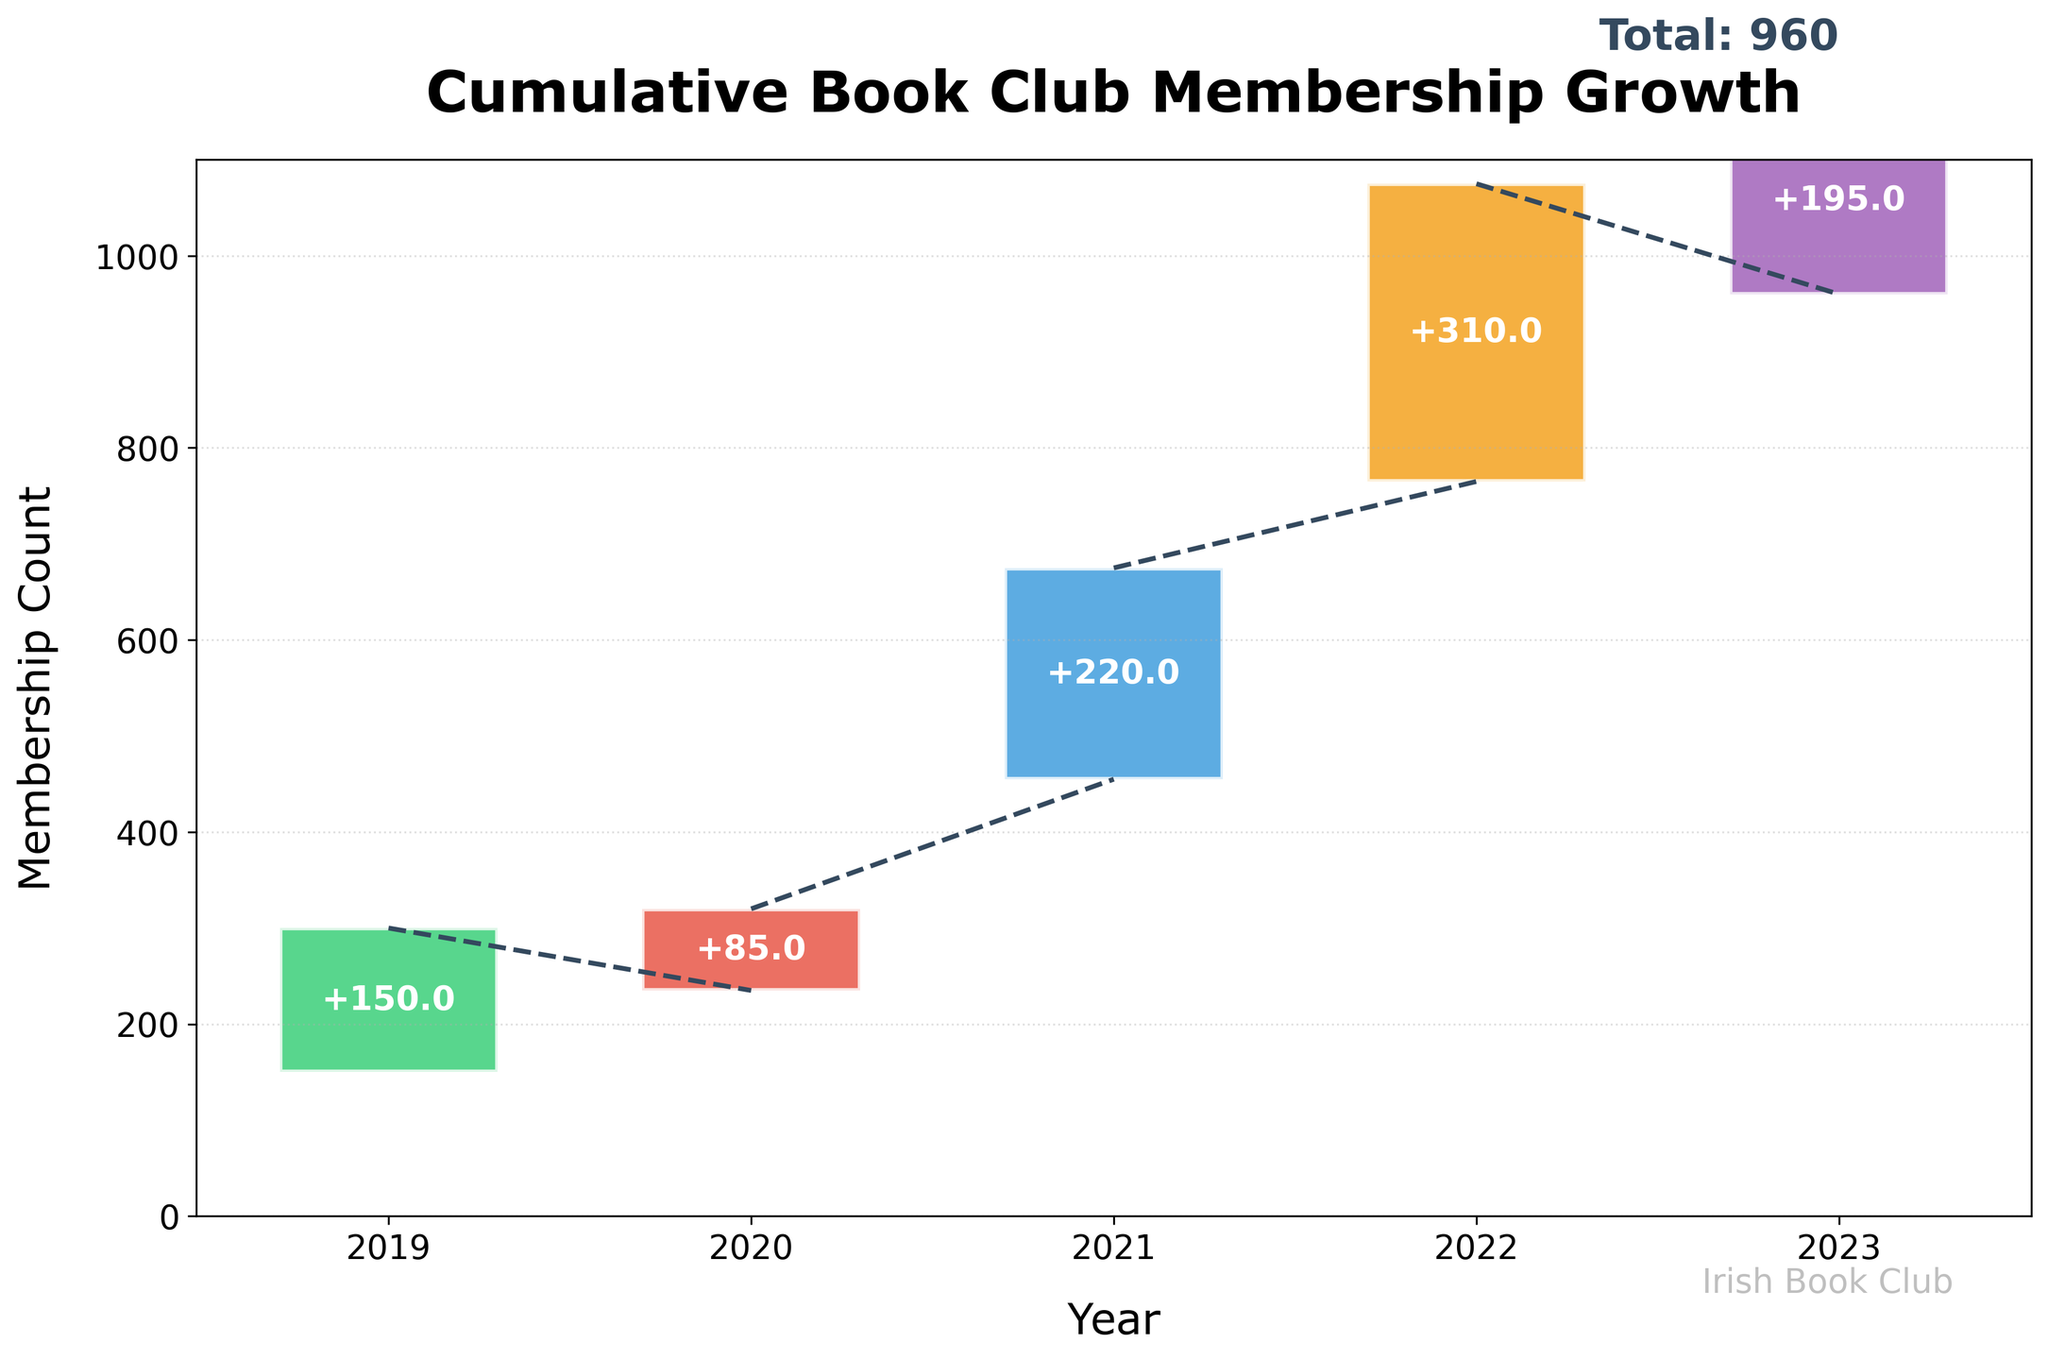How many years are displayed on the Waterfall Chart? The years are shown on the x-axis, where discrete points (bars) represent each year in the chart. By counting the bars from 2019 to 2023, there are 5 years.
Answer: 5 What is the total book club membership in 2023? The y-axis shows the cumulative membership count, and the top of the bar for 2023 represents the total. The labels above the bars also include the totals, which show 960 for 2023.
Answer: 960 Which year saw the highest growth in membership? By looking at the height of the bars representing the membership changes, the bar for 2022 is tallest. The label "+310" confirms the highest increase.
Answer: 2022 What is the membership change in year 2021? The chart shows the change in membership in the middle of each bar. For 2021, the bar is labeled "+220", which indicates an increase of 220 members.
Answer: 220 What is the average membership growth per year over the 5 years? To find the average growth, sum the changes displayed on the bars (150 + 85 + 220 + 310 + 195 = 960). Then, divide by the total number of years (5).
Answer: 192 How does the membership growth in 2020 compare to that in 2019? Comparing the labels, 2019 saw a growth of +150 while 2020 saw +85. Since 150 is greater than 85, 2019 had more growth.
Answer: 2019 had more growth Which year had the smallest increase in membership? Comparing the heights of the bars and their labels, 2020 has the smallest increase at +85.
Answer: 2020 What is the cumulative membership at the end of 2021? The cumulative membership at the top of the bar for 2021 is labeled as 455. This is also the starting point of the next bar for 2022.
Answer: 455 